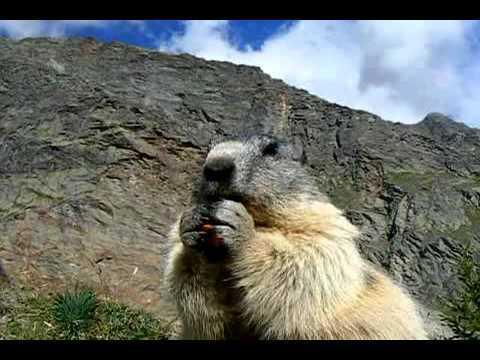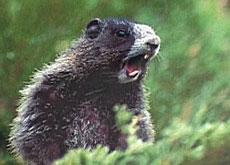The first image is the image on the left, the second image is the image on the right. For the images displayed, is the sentence "One image includes exactly twice as many marmots as the other image." factually correct? Answer yes or no. No. The first image is the image on the left, the second image is the image on the right. Assess this claim about the two images: "There are three marmots". Correct or not? Answer yes or no. No. 